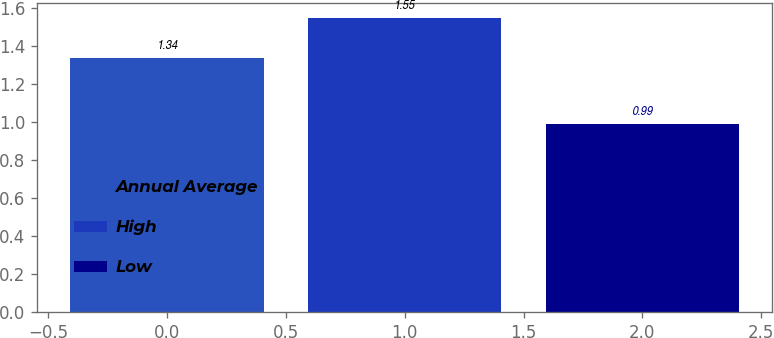Convert chart to OTSL. <chart><loc_0><loc_0><loc_500><loc_500><bar_chart><fcel>Annual Average<fcel>High<fcel>Low<nl><fcel>1.34<fcel>1.55<fcel>0.99<nl></chart> 